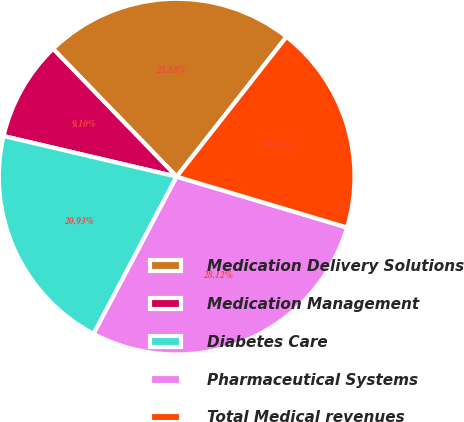<chart> <loc_0><loc_0><loc_500><loc_500><pie_chart><fcel>Medication Delivery Solutions<fcel>Medication Management<fcel>Diabetes Care<fcel>Pharmaceutical Systems<fcel>Total Medical revenues<nl><fcel>22.83%<fcel>9.1%<fcel>20.93%<fcel>28.12%<fcel>19.02%<nl></chart> 